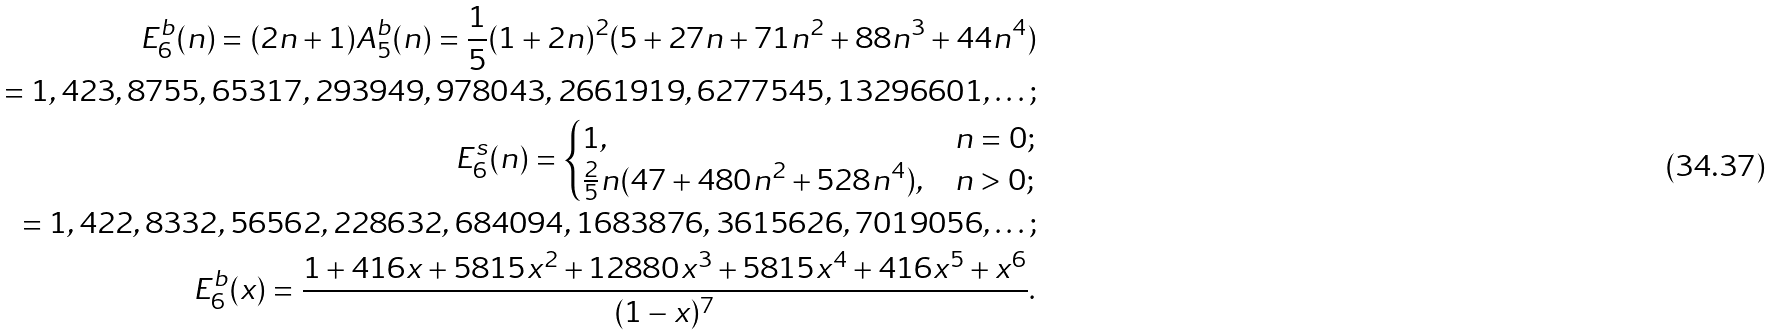<formula> <loc_0><loc_0><loc_500><loc_500>E _ { 6 } ^ { b } ( n ) = ( 2 n + 1 ) A _ { 5 } ^ { b } ( n ) = \frac { 1 } { 5 } ( 1 + 2 n ) ^ { 2 } ( 5 + 2 7 n + 7 1 n ^ { 2 } + 8 8 n ^ { 3 } + 4 4 n ^ { 4 } ) \\ = 1 , 4 2 3 , 8 7 5 5 , 6 5 3 1 7 , 2 9 3 9 4 9 , 9 7 8 0 4 3 , 2 6 6 1 9 1 9 , 6 2 7 7 5 4 5 , 1 3 2 9 6 6 0 1 , \dots ; \\ E _ { 6 } ^ { s } ( n ) = \begin{cases} 1 , & n = 0 ; \\ \frac { 2 } { 5 } n ( 4 7 + 4 8 0 n ^ { 2 } + 5 2 8 n ^ { 4 } ) , & n > 0 ; \\ \end{cases} \\ = 1 , 4 2 2 , 8 3 3 2 , 5 6 5 6 2 , 2 2 8 6 3 2 , 6 8 4 0 9 4 , 1 6 8 3 8 7 6 , 3 6 1 5 6 2 6 , 7 0 1 9 0 5 6 , \dots ; \\ E _ { 6 } ^ { b } ( x ) = \frac { 1 + 4 1 6 x + 5 8 1 5 x ^ { 2 } + 1 2 8 8 0 x ^ { 3 } + 5 8 1 5 x ^ { 4 } + 4 1 6 x ^ { 5 } + x ^ { 6 } } { ( 1 - x ) ^ { 7 } } .</formula> 